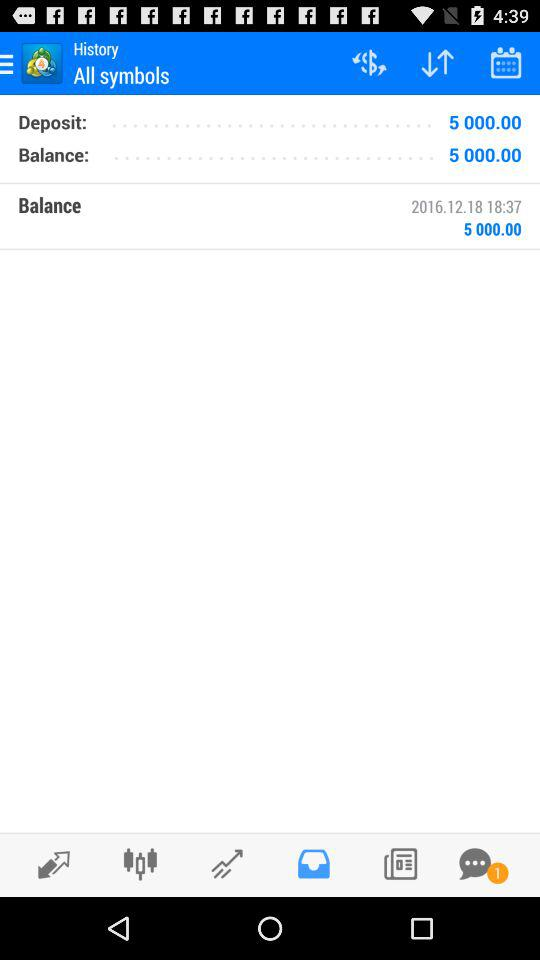How much is the deposited amount? The deposited amount is 5,000. 